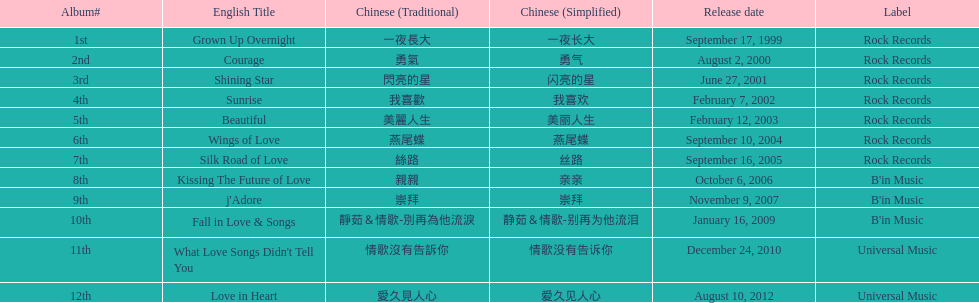Which english titles were published in even years? Courage, Sunrise, Silk Road of Love, Kissing The Future of Love, What Love Songs Didn't Tell You, Love in Heart. From the following, which one was released under b's in music? Kissing The Future of Love. 